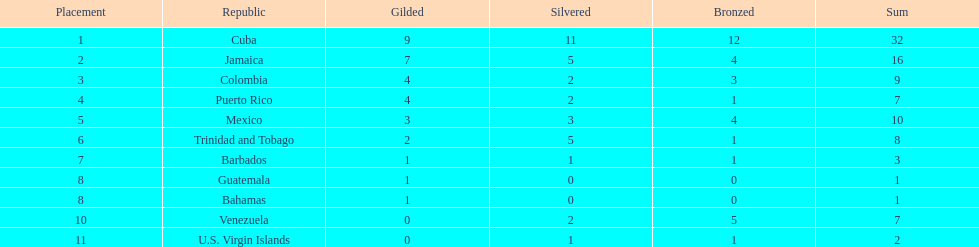What is the difference in medals between cuba and mexico? 22. 